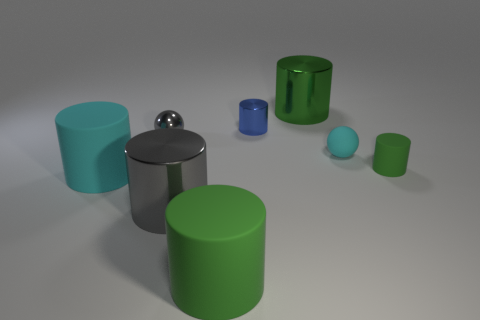Subtract all large green shiny cylinders. How many cylinders are left? 5 Subtract all gray balls. How many balls are left? 1 Subtract 1 spheres. How many spheres are left? 1 Subtract all balls. How many objects are left? 6 Add 1 cylinders. How many objects exist? 9 Subtract all brown balls. How many green cylinders are left? 3 Subtract 0 purple cylinders. How many objects are left? 8 Subtract all green balls. Subtract all blue cylinders. How many balls are left? 2 Subtract all gray metallic spheres. Subtract all green matte things. How many objects are left? 5 Add 5 small green matte things. How many small green matte things are left? 6 